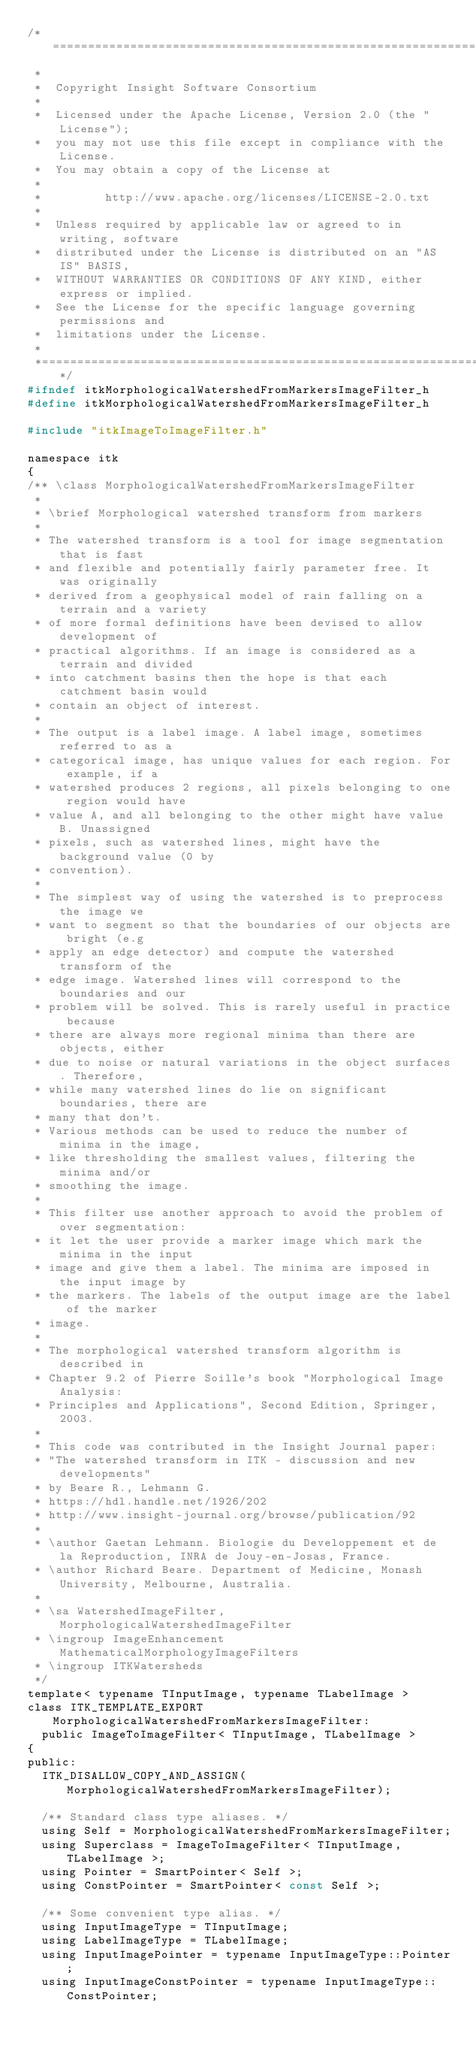<code> <loc_0><loc_0><loc_500><loc_500><_C_>/*=========================================================================
 *
 *  Copyright Insight Software Consortium
 *
 *  Licensed under the Apache License, Version 2.0 (the "License");
 *  you may not use this file except in compliance with the License.
 *  You may obtain a copy of the License at
 *
 *         http://www.apache.org/licenses/LICENSE-2.0.txt
 *
 *  Unless required by applicable law or agreed to in writing, software
 *  distributed under the License is distributed on an "AS IS" BASIS,
 *  WITHOUT WARRANTIES OR CONDITIONS OF ANY KIND, either express or implied.
 *  See the License for the specific language governing permissions and
 *  limitations under the License.
 *
 *=========================================================================*/
#ifndef itkMorphologicalWatershedFromMarkersImageFilter_h
#define itkMorphologicalWatershedFromMarkersImageFilter_h

#include "itkImageToImageFilter.h"

namespace itk
{
/** \class MorphologicalWatershedFromMarkersImageFilter
 *
 * \brief Morphological watershed transform from markers
 *
 * The watershed transform is a tool for image segmentation that is fast
 * and flexible and potentially fairly parameter free. It was originally
 * derived from a geophysical model of rain falling on a terrain and a variety
 * of more formal definitions have been devised to allow development of
 * practical algorithms. If an image is considered as a terrain and divided
 * into catchment basins then the hope is that each catchment basin would
 * contain an object of interest.
 *
 * The output is a label image. A label image, sometimes referred to as a
 * categorical image, has unique values for each region. For example, if a
 * watershed produces 2 regions, all pixels belonging to one region would have
 * value A, and all belonging to the other might have value B. Unassigned
 * pixels, such as watershed lines, might have the background value (0 by
 * convention).
 *
 * The simplest way of using the watershed is to preprocess the image we
 * want to segment so that the boundaries of our objects are bright (e.g
 * apply an edge detector) and compute the watershed transform of the
 * edge image. Watershed lines will correspond to the boundaries and our
 * problem will be solved. This is rarely useful in practice because
 * there are always more regional minima than there are objects, either
 * due to noise or natural variations in the object surfaces. Therefore,
 * while many watershed lines do lie on significant boundaries, there are
 * many that don't.
 * Various methods can be used to reduce the number of minima in the image,
 * like thresholding the smallest values, filtering the minima and/or
 * smoothing the image.
 *
 * This filter use another approach to avoid the problem of over segmentation:
 * it let the user provide a marker image which mark the minima in the input
 * image and give them a label. The minima are imposed in the input image by
 * the markers. The labels of the output image are the label of the marker
 * image.
 *
 * The morphological watershed transform algorithm is described in
 * Chapter 9.2 of Pierre Soille's book "Morphological Image Analysis:
 * Principles and Applications", Second Edition, Springer, 2003.
 *
 * This code was contributed in the Insight Journal paper:
 * "The watershed transform in ITK - discussion and new developments"
 * by Beare R., Lehmann G.
 * https://hdl.handle.net/1926/202
 * http://www.insight-journal.org/browse/publication/92
 *
 * \author Gaetan Lehmann. Biologie du Developpement et de la Reproduction, INRA de Jouy-en-Josas, France.
 * \author Richard Beare. Department of Medicine, Monash University, Melbourne, Australia.
 *
 * \sa WatershedImageFilter, MorphologicalWatershedImageFilter
 * \ingroup ImageEnhancement  MathematicalMorphologyImageFilters
 * \ingroup ITKWatersheds
 */
template< typename TInputImage, typename TLabelImage >
class ITK_TEMPLATE_EXPORT MorphologicalWatershedFromMarkersImageFilter:
  public ImageToImageFilter< TInputImage, TLabelImage >
{
public:
  ITK_DISALLOW_COPY_AND_ASSIGN(MorphologicalWatershedFromMarkersImageFilter);

  /** Standard class type aliases. */
  using Self = MorphologicalWatershedFromMarkersImageFilter;
  using Superclass = ImageToImageFilter< TInputImage, TLabelImage >;
  using Pointer = SmartPointer< Self >;
  using ConstPointer = SmartPointer< const Self >;

  /** Some convenient type alias. */
  using InputImageType = TInputImage;
  using LabelImageType = TLabelImage;
  using InputImagePointer = typename InputImageType::Pointer;
  using InputImageConstPointer = typename InputImageType::ConstPointer;</code> 